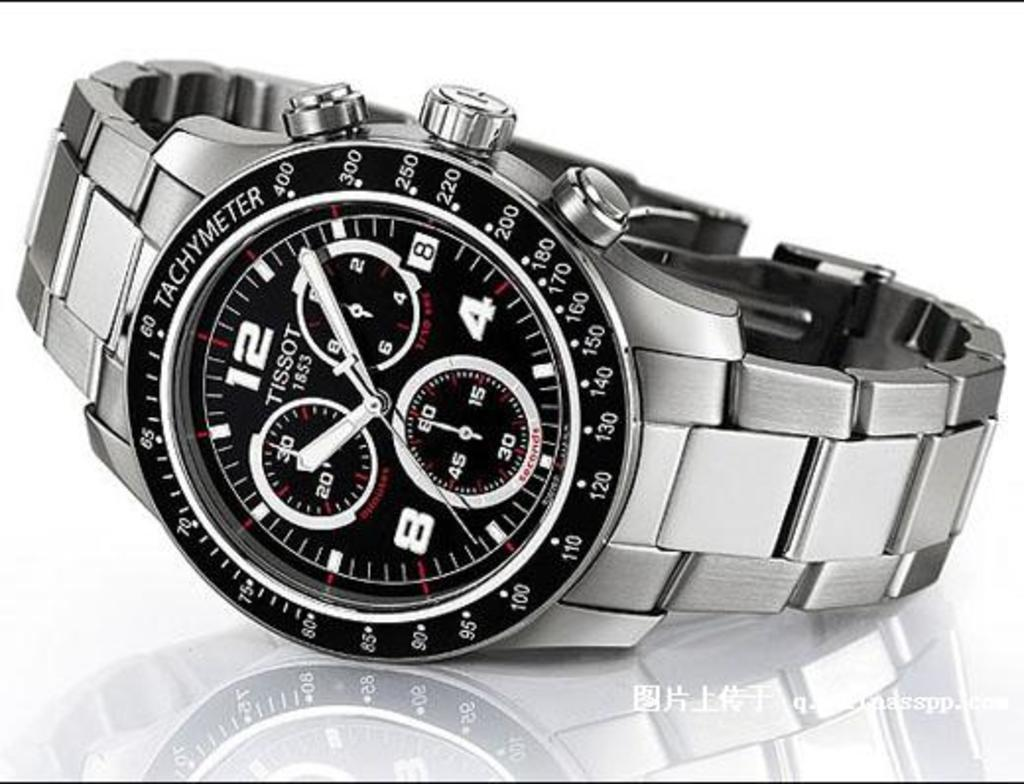<image>
Render a clear and concise summary of the photo. A picture of a black and silver Tissot watch. 